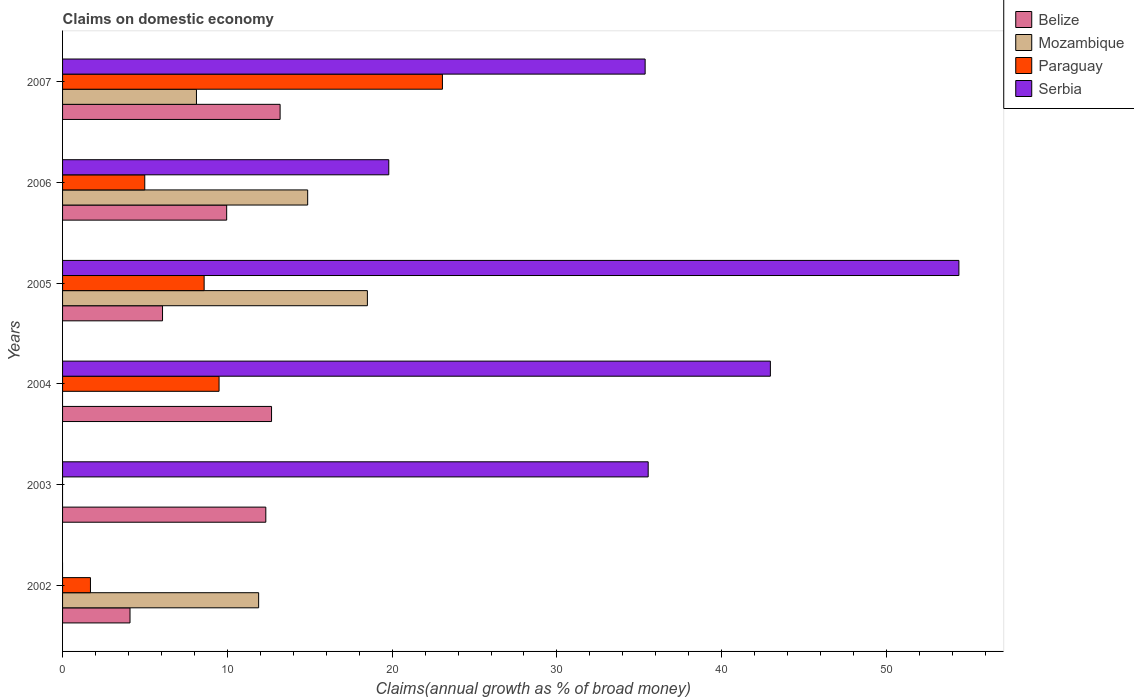How many groups of bars are there?
Your answer should be compact. 6. Are the number of bars per tick equal to the number of legend labels?
Keep it short and to the point. No. What is the percentage of broad money claimed on domestic economy in Mozambique in 2002?
Make the answer very short. 11.9. Across all years, what is the maximum percentage of broad money claimed on domestic economy in Belize?
Provide a succinct answer. 13.2. Across all years, what is the minimum percentage of broad money claimed on domestic economy in Belize?
Your answer should be compact. 4.09. In which year was the percentage of broad money claimed on domestic economy in Belize maximum?
Provide a succinct answer. 2007. What is the total percentage of broad money claimed on domestic economy in Belize in the graph?
Ensure brevity in your answer.  58.34. What is the difference between the percentage of broad money claimed on domestic economy in Paraguay in 2004 and that in 2006?
Offer a terse response. 4.51. What is the difference between the percentage of broad money claimed on domestic economy in Serbia in 2005 and the percentage of broad money claimed on domestic economy in Paraguay in 2002?
Make the answer very short. 52.7. What is the average percentage of broad money claimed on domestic economy in Paraguay per year?
Keep it short and to the point. 7.97. In the year 2002, what is the difference between the percentage of broad money claimed on domestic economy in Paraguay and percentage of broad money claimed on domestic economy in Belize?
Your response must be concise. -2.4. What is the ratio of the percentage of broad money claimed on domestic economy in Paraguay in 2002 to that in 2005?
Your answer should be very brief. 0.2. What is the difference between the highest and the second highest percentage of broad money claimed on domestic economy in Serbia?
Provide a short and direct response. 11.44. What is the difference between the highest and the lowest percentage of broad money claimed on domestic economy in Mozambique?
Provide a succinct answer. 18.5. Is it the case that in every year, the sum of the percentage of broad money claimed on domestic economy in Belize and percentage of broad money claimed on domestic economy in Mozambique is greater than the sum of percentage of broad money claimed on domestic economy in Paraguay and percentage of broad money claimed on domestic economy in Serbia?
Your answer should be compact. No. How many bars are there?
Ensure brevity in your answer.  20. Are all the bars in the graph horizontal?
Offer a terse response. Yes. How many years are there in the graph?
Provide a succinct answer. 6. Are the values on the major ticks of X-axis written in scientific E-notation?
Ensure brevity in your answer.  No. Does the graph contain any zero values?
Offer a very short reply. Yes. How many legend labels are there?
Your response must be concise. 4. What is the title of the graph?
Offer a very short reply. Claims on domestic economy. Does "Oman" appear as one of the legend labels in the graph?
Give a very brief answer. No. What is the label or title of the X-axis?
Your response must be concise. Claims(annual growth as % of broad money). What is the label or title of the Y-axis?
Keep it short and to the point. Years. What is the Claims(annual growth as % of broad money) in Belize in 2002?
Give a very brief answer. 4.09. What is the Claims(annual growth as % of broad money) of Mozambique in 2002?
Keep it short and to the point. 11.9. What is the Claims(annual growth as % of broad money) of Paraguay in 2002?
Your answer should be very brief. 1.69. What is the Claims(annual growth as % of broad money) in Serbia in 2002?
Your answer should be very brief. 0. What is the Claims(annual growth as % of broad money) in Belize in 2003?
Keep it short and to the point. 12.33. What is the Claims(annual growth as % of broad money) of Paraguay in 2003?
Your answer should be compact. 0. What is the Claims(annual growth as % of broad money) of Serbia in 2003?
Give a very brief answer. 35.54. What is the Claims(annual growth as % of broad money) in Belize in 2004?
Ensure brevity in your answer.  12.68. What is the Claims(annual growth as % of broad money) of Mozambique in 2004?
Your response must be concise. 0. What is the Claims(annual growth as % of broad money) of Paraguay in 2004?
Ensure brevity in your answer.  9.5. What is the Claims(annual growth as % of broad money) in Serbia in 2004?
Ensure brevity in your answer.  42.96. What is the Claims(annual growth as % of broad money) in Belize in 2005?
Keep it short and to the point. 6.07. What is the Claims(annual growth as % of broad money) in Mozambique in 2005?
Offer a terse response. 18.5. What is the Claims(annual growth as % of broad money) in Paraguay in 2005?
Provide a short and direct response. 8.59. What is the Claims(annual growth as % of broad money) in Serbia in 2005?
Make the answer very short. 54.4. What is the Claims(annual growth as % of broad money) of Belize in 2006?
Keep it short and to the point. 9.96. What is the Claims(annual growth as % of broad money) in Mozambique in 2006?
Provide a short and direct response. 14.87. What is the Claims(annual growth as % of broad money) of Paraguay in 2006?
Your answer should be compact. 4.99. What is the Claims(annual growth as % of broad money) of Serbia in 2006?
Make the answer very short. 19.8. What is the Claims(annual growth as % of broad money) in Belize in 2007?
Make the answer very short. 13.2. What is the Claims(annual growth as % of broad money) of Mozambique in 2007?
Give a very brief answer. 8.13. What is the Claims(annual growth as % of broad money) of Paraguay in 2007?
Offer a terse response. 23.05. What is the Claims(annual growth as % of broad money) of Serbia in 2007?
Ensure brevity in your answer.  35.36. Across all years, what is the maximum Claims(annual growth as % of broad money) of Belize?
Keep it short and to the point. 13.2. Across all years, what is the maximum Claims(annual growth as % of broad money) in Mozambique?
Give a very brief answer. 18.5. Across all years, what is the maximum Claims(annual growth as % of broad money) in Paraguay?
Ensure brevity in your answer.  23.05. Across all years, what is the maximum Claims(annual growth as % of broad money) in Serbia?
Provide a succinct answer. 54.4. Across all years, what is the minimum Claims(annual growth as % of broad money) in Belize?
Provide a short and direct response. 4.09. What is the total Claims(annual growth as % of broad money) in Belize in the graph?
Your answer should be compact. 58.34. What is the total Claims(annual growth as % of broad money) of Mozambique in the graph?
Keep it short and to the point. 53.4. What is the total Claims(annual growth as % of broad money) of Paraguay in the graph?
Make the answer very short. 47.82. What is the total Claims(annual growth as % of broad money) in Serbia in the graph?
Offer a very short reply. 188.04. What is the difference between the Claims(annual growth as % of broad money) of Belize in 2002 and that in 2003?
Offer a very short reply. -8.24. What is the difference between the Claims(annual growth as % of broad money) in Belize in 2002 and that in 2004?
Make the answer very short. -8.59. What is the difference between the Claims(annual growth as % of broad money) in Paraguay in 2002 and that in 2004?
Your answer should be compact. -7.81. What is the difference between the Claims(annual growth as % of broad money) in Belize in 2002 and that in 2005?
Make the answer very short. -1.97. What is the difference between the Claims(annual growth as % of broad money) of Mozambique in 2002 and that in 2005?
Keep it short and to the point. -6.6. What is the difference between the Claims(annual growth as % of broad money) in Paraguay in 2002 and that in 2005?
Make the answer very short. -6.9. What is the difference between the Claims(annual growth as % of broad money) of Belize in 2002 and that in 2006?
Provide a succinct answer. -5.87. What is the difference between the Claims(annual growth as % of broad money) in Mozambique in 2002 and that in 2006?
Your answer should be very brief. -2.98. What is the difference between the Claims(annual growth as % of broad money) in Paraguay in 2002 and that in 2006?
Make the answer very short. -3.3. What is the difference between the Claims(annual growth as % of broad money) in Belize in 2002 and that in 2007?
Give a very brief answer. -9.11. What is the difference between the Claims(annual growth as % of broad money) of Mozambique in 2002 and that in 2007?
Provide a succinct answer. 3.77. What is the difference between the Claims(annual growth as % of broad money) of Paraguay in 2002 and that in 2007?
Provide a succinct answer. -21.36. What is the difference between the Claims(annual growth as % of broad money) of Belize in 2003 and that in 2004?
Keep it short and to the point. -0.35. What is the difference between the Claims(annual growth as % of broad money) of Serbia in 2003 and that in 2004?
Your answer should be very brief. -7.42. What is the difference between the Claims(annual growth as % of broad money) in Belize in 2003 and that in 2005?
Offer a very short reply. 6.27. What is the difference between the Claims(annual growth as % of broad money) in Serbia in 2003 and that in 2005?
Offer a very short reply. -18.86. What is the difference between the Claims(annual growth as % of broad money) of Belize in 2003 and that in 2006?
Your answer should be compact. 2.38. What is the difference between the Claims(annual growth as % of broad money) in Serbia in 2003 and that in 2006?
Provide a short and direct response. 15.74. What is the difference between the Claims(annual growth as % of broad money) in Belize in 2003 and that in 2007?
Provide a short and direct response. -0.87. What is the difference between the Claims(annual growth as % of broad money) of Serbia in 2003 and that in 2007?
Offer a very short reply. 0.18. What is the difference between the Claims(annual growth as % of broad money) of Belize in 2004 and that in 2005?
Provide a short and direct response. 6.62. What is the difference between the Claims(annual growth as % of broad money) in Paraguay in 2004 and that in 2005?
Your answer should be very brief. 0.91. What is the difference between the Claims(annual growth as % of broad money) of Serbia in 2004 and that in 2005?
Your answer should be compact. -11.44. What is the difference between the Claims(annual growth as % of broad money) in Belize in 2004 and that in 2006?
Ensure brevity in your answer.  2.72. What is the difference between the Claims(annual growth as % of broad money) of Paraguay in 2004 and that in 2006?
Offer a very short reply. 4.51. What is the difference between the Claims(annual growth as % of broad money) in Serbia in 2004 and that in 2006?
Your answer should be very brief. 23.16. What is the difference between the Claims(annual growth as % of broad money) of Belize in 2004 and that in 2007?
Give a very brief answer. -0.52. What is the difference between the Claims(annual growth as % of broad money) in Paraguay in 2004 and that in 2007?
Give a very brief answer. -13.56. What is the difference between the Claims(annual growth as % of broad money) in Serbia in 2004 and that in 2007?
Your answer should be very brief. 7.6. What is the difference between the Claims(annual growth as % of broad money) in Belize in 2005 and that in 2006?
Keep it short and to the point. -3.89. What is the difference between the Claims(annual growth as % of broad money) in Mozambique in 2005 and that in 2006?
Ensure brevity in your answer.  3.62. What is the difference between the Claims(annual growth as % of broad money) of Paraguay in 2005 and that in 2006?
Offer a very short reply. 3.6. What is the difference between the Claims(annual growth as % of broad money) of Serbia in 2005 and that in 2006?
Offer a very short reply. 34.6. What is the difference between the Claims(annual growth as % of broad money) of Belize in 2005 and that in 2007?
Keep it short and to the point. -7.14. What is the difference between the Claims(annual growth as % of broad money) of Mozambique in 2005 and that in 2007?
Provide a succinct answer. 10.37. What is the difference between the Claims(annual growth as % of broad money) of Paraguay in 2005 and that in 2007?
Your answer should be very brief. -14.46. What is the difference between the Claims(annual growth as % of broad money) in Serbia in 2005 and that in 2007?
Give a very brief answer. 19.04. What is the difference between the Claims(annual growth as % of broad money) in Belize in 2006 and that in 2007?
Your response must be concise. -3.24. What is the difference between the Claims(annual growth as % of broad money) in Mozambique in 2006 and that in 2007?
Ensure brevity in your answer.  6.75. What is the difference between the Claims(annual growth as % of broad money) of Paraguay in 2006 and that in 2007?
Ensure brevity in your answer.  -18.06. What is the difference between the Claims(annual growth as % of broad money) of Serbia in 2006 and that in 2007?
Your answer should be very brief. -15.56. What is the difference between the Claims(annual growth as % of broad money) of Belize in 2002 and the Claims(annual growth as % of broad money) of Serbia in 2003?
Offer a terse response. -31.45. What is the difference between the Claims(annual growth as % of broad money) of Mozambique in 2002 and the Claims(annual growth as % of broad money) of Serbia in 2003?
Give a very brief answer. -23.64. What is the difference between the Claims(annual growth as % of broad money) of Paraguay in 2002 and the Claims(annual growth as % of broad money) of Serbia in 2003?
Ensure brevity in your answer.  -33.85. What is the difference between the Claims(annual growth as % of broad money) in Belize in 2002 and the Claims(annual growth as % of broad money) in Paraguay in 2004?
Keep it short and to the point. -5.4. What is the difference between the Claims(annual growth as % of broad money) in Belize in 2002 and the Claims(annual growth as % of broad money) in Serbia in 2004?
Your answer should be very brief. -38.86. What is the difference between the Claims(annual growth as % of broad money) of Mozambique in 2002 and the Claims(annual growth as % of broad money) of Paraguay in 2004?
Keep it short and to the point. 2.4. What is the difference between the Claims(annual growth as % of broad money) in Mozambique in 2002 and the Claims(annual growth as % of broad money) in Serbia in 2004?
Ensure brevity in your answer.  -31.06. What is the difference between the Claims(annual growth as % of broad money) in Paraguay in 2002 and the Claims(annual growth as % of broad money) in Serbia in 2004?
Provide a succinct answer. -41.26. What is the difference between the Claims(annual growth as % of broad money) in Belize in 2002 and the Claims(annual growth as % of broad money) in Mozambique in 2005?
Provide a succinct answer. -14.41. What is the difference between the Claims(annual growth as % of broad money) of Belize in 2002 and the Claims(annual growth as % of broad money) of Paraguay in 2005?
Keep it short and to the point. -4.5. What is the difference between the Claims(annual growth as % of broad money) in Belize in 2002 and the Claims(annual growth as % of broad money) in Serbia in 2005?
Your response must be concise. -50.3. What is the difference between the Claims(annual growth as % of broad money) in Mozambique in 2002 and the Claims(annual growth as % of broad money) in Paraguay in 2005?
Keep it short and to the point. 3.31. What is the difference between the Claims(annual growth as % of broad money) of Mozambique in 2002 and the Claims(annual growth as % of broad money) of Serbia in 2005?
Ensure brevity in your answer.  -42.5. What is the difference between the Claims(annual growth as % of broad money) in Paraguay in 2002 and the Claims(annual growth as % of broad money) in Serbia in 2005?
Offer a terse response. -52.7. What is the difference between the Claims(annual growth as % of broad money) in Belize in 2002 and the Claims(annual growth as % of broad money) in Mozambique in 2006?
Ensure brevity in your answer.  -10.78. What is the difference between the Claims(annual growth as % of broad money) of Belize in 2002 and the Claims(annual growth as % of broad money) of Paraguay in 2006?
Offer a very short reply. -0.9. What is the difference between the Claims(annual growth as % of broad money) in Belize in 2002 and the Claims(annual growth as % of broad money) in Serbia in 2006?
Keep it short and to the point. -15.7. What is the difference between the Claims(annual growth as % of broad money) in Mozambique in 2002 and the Claims(annual growth as % of broad money) in Paraguay in 2006?
Provide a succinct answer. 6.91. What is the difference between the Claims(annual growth as % of broad money) in Mozambique in 2002 and the Claims(annual growth as % of broad money) in Serbia in 2006?
Provide a succinct answer. -7.9. What is the difference between the Claims(annual growth as % of broad money) in Paraguay in 2002 and the Claims(annual growth as % of broad money) in Serbia in 2006?
Ensure brevity in your answer.  -18.1. What is the difference between the Claims(annual growth as % of broad money) of Belize in 2002 and the Claims(annual growth as % of broad money) of Mozambique in 2007?
Offer a terse response. -4.03. What is the difference between the Claims(annual growth as % of broad money) of Belize in 2002 and the Claims(annual growth as % of broad money) of Paraguay in 2007?
Provide a short and direct response. -18.96. What is the difference between the Claims(annual growth as % of broad money) in Belize in 2002 and the Claims(annual growth as % of broad money) in Serbia in 2007?
Keep it short and to the point. -31.26. What is the difference between the Claims(annual growth as % of broad money) in Mozambique in 2002 and the Claims(annual growth as % of broad money) in Paraguay in 2007?
Your answer should be compact. -11.15. What is the difference between the Claims(annual growth as % of broad money) in Mozambique in 2002 and the Claims(annual growth as % of broad money) in Serbia in 2007?
Make the answer very short. -23.46. What is the difference between the Claims(annual growth as % of broad money) of Paraguay in 2002 and the Claims(annual growth as % of broad money) of Serbia in 2007?
Offer a terse response. -33.66. What is the difference between the Claims(annual growth as % of broad money) of Belize in 2003 and the Claims(annual growth as % of broad money) of Paraguay in 2004?
Provide a succinct answer. 2.84. What is the difference between the Claims(annual growth as % of broad money) of Belize in 2003 and the Claims(annual growth as % of broad money) of Serbia in 2004?
Provide a short and direct response. -30.62. What is the difference between the Claims(annual growth as % of broad money) of Belize in 2003 and the Claims(annual growth as % of broad money) of Mozambique in 2005?
Provide a succinct answer. -6.16. What is the difference between the Claims(annual growth as % of broad money) in Belize in 2003 and the Claims(annual growth as % of broad money) in Paraguay in 2005?
Ensure brevity in your answer.  3.74. What is the difference between the Claims(annual growth as % of broad money) in Belize in 2003 and the Claims(annual growth as % of broad money) in Serbia in 2005?
Make the answer very short. -42.06. What is the difference between the Claims(annual growth as % of broad money) of Belize in 2003 and the Claims(annual growth as % of broad money) of Mozambique in 2006?
Provide a short and direct response. -2.54. What is the difference between the Claims(annual growth as % of broad money) of Belize in 2003 and the Claims(annual growth as % of broad money) of Paraguay in 2006?
Provide a succinct answer. 7.35. What is the difference between the Claims(annual growth as % of broad money) of Belize in 2003 and the Claims(annual growth as % of broad money) of Serbia in 2006?
Offer a terse response. -7.46. What is the difference between the Claims(annual growth as % of broad money) of Belize in 2003 and the Claims(annual growth as % of broad money) of Mozambique in 2007?
Your answer should be compact. 4.21. What is the difference between the Claims(annual growth as % of broad money) of Belize in 2003 and the Claims(annual growth as % of broad money) of Paraguay in 2007?
Give a very brief answer. -10.72. What is the difference between the Claims(annual growth as % of broad money) of Belize in 2003 and the Claims(annual growth as % of broad money) of Serbia in 2007?
Make the answer very short. -23.02. What is the difference between the Claims(annual growth as % of broad money) of Belize in 2004 and the Claims(annual growth as % of broad money) of Mozambique in 2005?
Make the answer very short. -5.82. What is the difference between the Claims(annual growth as % of broad money) in Belize in 2004 and the Claims(annual growth as % of broad money) in Paraguay in 2005?
Your answer should be compact. 4.09. What is the difference between the Claims(annual growth as % of broad money) in Belize in 2004 and the Claims(annual growth as % of broad money) in Serbia in 2005?
Offer a very short reply. -41.71. What is the difference between the Claims(annual growth as % of broad money) in Paraguay in 2004 and the Claims(annual growth as % of broad money) in Serbia in 2005?
Give a very brief answer. -44.9. What is the difference between the Claims(annual growth as % of broad money) of Belize in 2004 and the Claims(annual growth as % of broad money) of Mozambique in 2006?
Keep it short and to the point. -2.19. What is the difference between the Claims(annual growth as % of broad money) in Belize in 2004 and the Claims(annual growth as % of broad money) in Paraguay in 2006?
Keep it short and to the point. 7.69. What is the difference between the Claims(annual growth as % of broad money) in Belize in 2004 and the Claims(annual growth as % of broad money) in Serbia in 2006?
Make the answer very short. -7.11. What is the difference between the Claims(annual growth as % of broad money) of Paraguay in 2004 and the Claims(annual growth as % of broad money) of Serbia in 2006?
Your answer should be compact. -10.3. What is the difference between the Claims(annual growth as % of broad money) in Belize in 2004 and the Claims(annual growth as % of broad money) in Mozambique in 2007?
Keep it short and to the point. 4.56. What is the difference between the Claims(annual growth as % of broad money) in Belize in 2004 and the Claims(annual growth as % of broad money) in Paraguay in 2007?
Provide a succinct answer. -10.37. What is the difference between the Claims(annual growth as % of broad money) of Belize in 2004 and the Claims(annual growth as % of broad money) of Serbia in 2007?
Your response must be concise. -22.67. What is the difference between the Claims(annual growth as % of broad money) in Paraguay in 2004 and the Claims(annual growth as % of broad money) in Serbia in 2007?
Provide a short and direct response. -25.86. What is the difference between the Claims(annual growth as % of broad money) of Belize in 2005 and the Claims(annual growth as % of broad money) of Mozambique in 2006?
Give a very brief answer. -8.81. What is the difference between the Claims(annual growth as % of broad money) of Belize in 2005 and the Claims(annual growth as % of broad money) of Paraguay in 2006?
Your response must be concise. 1.08. What is the difference between the Claims(annual growth as % of broad money) in Belize in 2005 and the Claims(annual growth as % of broad money) in Serbia in 2006?
Give a very brief answer. -13.73. What is the difference between the Claims(annual growth as % of broad money) in Mozambique in 2005 and the Claims(annual growth as % of broad money) in Paraguay in 2006?
Offer a terse response. 13.51. What is the difference between the Claims(annual growth as % of broad money) of Mozambique in 2005 and the Claims(annual growth as % of broad money) of Serbia in 2006?
Provide a succinct answer. -1.3. What is the difference between the Claims(annual growth as % of broad money) of Paraguay in 2005 and the Claims(annual growth as % of broad money) of Serbia in 2006?
Make the answer very short. -11.21. What is the difference between the Claims(annual growth as % of broad money) in Belize in 2005 and the Claims(annual growth as % of broad money) in Mozambique in 2007?
Ensure brevity in your answer.  -2.06. What is the difference between the Claims(annual growth as % of broad money) in Belize in 2005 and the Claims(annual growth as % of broad money) in Paraguay in 2007?
Give a very brief answer. -16.99. What is the difference between the Claims(annual growth as % of broad money) of Belize in 2005 and the Claims(annual growth as % of broad money) of Serbia in 2007?
Your response must be concise. -29.29. What is the difference between the Claims(annual growth as % of broad money) of Mozambique in 2005 and the Claims(annual growth as % of broad money) of Paraguay in 2007?
Your answer should be very brief. -4.55. What is the difference between the Claims(annual growth as % of broad money) of Mozambique in 2005 and the Claims(annual growth as % of broad money) of Serbia in 2007?
Provide a short and direct response. -16.86. What is the difference between the Claims(annual growth as % of broad money) in Paraguay in 2005 and the Claims(annual growth as % of broad money) in Serbia in 2007?
Give a very brief answer. -26.76. What is the difference between the Claims(annual growth as % of broad money) in Belize in 2006 and the Claims(annual growth as % of broad money) in Mozambique in 2007?
Provide a succinct answer. 1.83. What is the difference between the Claims(annual growth as % of broad money) of Belize in 2006 and the Claims(annual growth as % of broad money) of Paraguay in 2007?
Ensure brevity in your answer.  -13.09. What is the difference between the Claims(annual growth as % of broad money) in Belize in 2006 and the Claims(annual growth as % of broad money) in Serbia in 2007?
Give a very brief answer. -25.4. What is the difference between the Claims(annual growth as % of broad money) of Mozambique in 2006 and the Claims(annual growth as % of broad money) of Paraguay in 2007?
Keep it short and to the point. -8.18. What is the difference between the Claims(annual growth as % of broad money) of Mozambique in 2006 and the Claims(annual growth as % of broad money) of Serbia in 2007?
Your response must be concise. -20.48. What is the difference between the Claims(annual growth as % of broad money) in Paraguay in 2006 and the Claims(annual growth as % of broad money) in Serbia in 2007?
Provide a succinct answer. -30.37. What is the average Claims(annual growth as % of broad money) in Belize per year?
Provide a short and direct response. 9.72. What is the average Claims(annual growth as % of broad money) in Mozambique per year?
Your response must be concise. 8.9. What is the average Claims(annual growth as % of broad money) in Paraguay per year?
Your answer should be very brief. 7.97. What is the average Claims(annual growth as % of broad money) in Serbia per year?
Your answer should be very brief. 31.34. In the year 2002, what is the difference between the Claims(annual growth as % of broad money) in Belize and Claims(annual growth as % of broad money) in Mozambique?
Your response must be concise. -7.81. In the year 2002, what is the difference between the Claims(annual growth as % of broad money) in Belize and Claims(annual growth as % of broad money) in Paraguay?
Provide a short and direct response. 2.4. In the year 2002, what is the difference between the Claims(annual growth as % of broad money) in Mozambique and Claims(annual growth as % of broad money) in Paraguay?
Provide a short and direct response. 10.21. In the year 2003, what is the difference between the Claims(annual growth as % of broad money) of Belize and Claims(annual growth as % of broad money) of Serbia?
Ensure brevity in your answer.  -23.2. In the year 2004, what is the difference between the Claims(annual growth as % of broad money) of Belize and Claims(annual growth as % of broad money) of Paraguay?
Offer a very short reply. 3.19. In the year 2004, what is the difference between the Claims(annual growth as % of broad money) of Belize and Claims(annual growth as % of broad money) of Serbia?
Ensure brevity in your answer.  -30.27. In the year 2004, what is the difference between the Claims(annual growth as % of broad money) of Paraguay and Claims(annual growth as % of broad money) of Serbia?
Keep it short and to the point. -33.46. In the year 2005, what is the difference between the Claims(annual growth as % of broad money) of Belize and Claims(annual growth as % of broad money) of Mozambique?
Offer a terse response. -12.43. In the year 2005, what is the difference between the Claims(annual growth as % of broad money) of Belize and Claims(annual growth as % of broad money) of Paraguay?
Provide a short and direct response. -2.53. In the year 2005, what is the difference between the Claims(annual growth as % of broad money) of Belize and Claims(annual growth as % of broad money) of Serbia?
Your answer should be very brief. -48.33. In the year 2005, what is the difference between the Claims(annual growth as % of broad money) of Mozambique and Claims(annual growth as % of broad money) of Paraguay?
Offer a terse response. 9.91. In the year 2005, what is the difference between the Claims(annual growth as % of broad money) of Mozambique and Claims(annual growth as % of broad money) of Serbia?
Offer a terse response. -35.9. In the year 2005, what is the difference between the Claims(annual growth as % of broad money) of Paraguay and Claims(annual growth as % of broad money) of Serbia?
Provide a short and direct response. -45.8. In the year 2006, what is the difference between the Claims(annual growth as % of broad money) in Belize and Claims(annual growth as % of broad money) in Mozambique?
Your answer should be compact. -4.92. In the year 2006, what is the difference between the Claims(annual growth as % of broad money) of Belize and Claims(annual growth as % of broad money) of Paraguay?
Your answer should be compact. 4.97. In the year 2006, what is the difference between the Claims(annual growth as % of broad money) in Belize and Claims(annual growth as % of broad money) in Serbia?
Your response must be concise. -9.84. In the year 2006, what is the difference between the Claims(annual growth as % of broad money) of Mozambique and Claims(annual growth as % of broad money) of Paraguay?
Offer a terse response. 9.89. In the year 2006, what is the difference between the Claims(annual growth as % of broad money) of Mozambique and Claims(annual growth as % of broad money) of Serbia?
Offer a very short reply. -4.92. In the year 2006, what is the difference between the Claims(annual growth as % of broad money) of Paraguay and Claims(annual growth as % of broad money) of Serbia?
Offer a terse response. -14.81. In the year 2007, what is the difference between the Claims(annual growth as % of broad money) in Belize and Claims(annual growth as % of broad money) in Mozambique?
Provide a succinct answer. 5.08. In the year 2007, what is the difference between the Claims(annual growth as % of broad money) of Belize and Claims(annual growth as % of broad money) of Paraguay?
Offer a very short reply. -9.85. In the year 2007, what is the difference between the Claims(annual growth as % of broad money) in Belize and Claims(annual growth as % of broad money) in Serbia?
Your answer should be compact. -22.15. In the year 2007, what is the difference between the Claims(annual growth as % of broad money) in Mozambique and Claims(annual growth as % of broad money) in Paraguay?
Provide a short and direct response. -14.93. In the year 2007, what is the difference between the Claims(annual growth as % of broad money) in Mozambique and Claims(annual growth as % of broad money) in Serbia?
Your answer should be compact. -27.23. In the year 2007, what is the difference between the Claims(annual growth as % of broad money) in Paraguay and Claims(annual growth as % of broad money) in Serbia?
Your answer should be compact. -12.3. What is the ratio of the Claims(annual growth as % of broad money) of Belize in 2002 to that in 2003?
Keep it short and to the point. 0.33. What is the ratio of the Claims(annual growth as % of broad money) of Belize in 2002 to that in 2004?
Give a very brief answer. 0.32. What is the ratio of the Claims(annual growth as % of broad money) in Paraguay in 2002 to that in 2004?
Offer a terse response. 0.18. What is the ratio of the Claims(annual growth as % of broad money) of Belize in 2002 to that in 2005?
Your response must be concise. 0.67. What is the ratio of the Claims(annual growth as % of broad money) of Mozambique in 2002 to that in 2005?
Make the answer very short. 0.64. What is the ratio of the Claims(annual growth as % of broad money) of Paraguay in 2002 to that in 2005?
Ensure brevity in your answer.  0.2. What is the ratio of the Claims(annual growth as % of broad money) in Belize in 2002 to that in 2006?
Ensure brevity in your answer.  0.41. What is the ratio of the Claims(annual growth as % of broad money) of Paraguay in 2002 to that in 2006?
Offer a very short reply. 0.34. What is the ratio of the Claims(annual growth as % of broad money) in Belize in 2002 to that in 2007?
Provide a succinct answer. 0.31. What is the ratio of the Claims(annual growth as % of broad money) in Mozambique in 2002 to that in 2007?
Your answer should be very brief. 1.46. What is the ratio of the Claims(annual growth as % of broad money) in Paraguay in 2002 to that in 2007?
Ensure brevity in your answer.  0.07. What is the ratio of the Claims(annual growth as % of broad money) of Belize in 2003 to that in 2004?
Provide a succinct answer. 0.97. What is the ratio of the Claims(annual growth as % of broad money) of Serbia in 2003 to that in 2004?
Provide a short and direct response. 0.83. What is the ratio of the Claims(annual growth as % of broad money) of Belize in 2003 to that in 2005?
Your answer should be compact. 2.03. What is the ratio of the Claims(annual growth as % of broad money) in Serbia in 2003 to that in 2005?
Your answer should be compact. 0.65. What is the ratio of the Claims(annual growth as % of broad money) in Belize in 2003 to that in 2006?
Ensure brevity in your answer.  1.24. What is the ratio of the Claims(annual growth as % of broad money) of Serbia in 2003 to that in 2006?
Make the answer very short. 1.8. What is the ratio of the Claims(annual growth as % of broad money) of Belize in 2003 to that in 2007?
Make the answer very short. 0.93. What is the ratio of the Claims(annual growth as % of broad money) in Belize in 2004 to that in 2005?
Provide a succinct answer. 2.09. What is the ratio of the Claims(annual growth as % of broad money) of Paraguay in 2004 to that in 2005?
Ensure brevity in your answer.  1.11. What is the ratio of the Claims(annual growth as % of broad money) of Serbia in 2004 to that in 2005?
Provide a short and direct response. 0.79. What is the ratio of the Claims(annual growth as % of broad money) in Belize in 2004 to that in 2006?
Provide a short and direct response. 1.27. What is the ratio of the Claims(annual growth as % of broad money) in Paraguay in 2004 to that in 2006?
Offer a terse response. 1.9. What is the ratio of the Claims(annual growth as % of broad money) in Serbia in 2004 to that in 2006?
Your response must be concise. 2.17. What is the ratio of the Claims(annual growth as % of broad money) of Belize in 2004 to that in 2007?
Provide a succinct answer. 0.96. What is the ratio of the Claims(annual growth as % of broad money) in Paraguay in 2004 to that in 2007?
Provide a short and direct response. 0.41. What is the ratio of the Claims(annual growth as % of broad money) in Serbia in 2004 to that in 2007?
Your response must be concise. 1.22. What is the ratio of the Claims(annual growth as % of broad money) of Belize in 2005 to that in 2006?
Provide a succinct answer. 0.61. What is the ratio of the Claims(annual growth as % of broad money) of Mozambique in 2005 to that in 2006?
Provide a succinct answer. 1.24. What is the ratio of the Claims(annual growth as % of broad money) in Paraguay in 2005 to that in 2006?
Offer a terse response. 1.72. What is the ratio of the Claims(annual growth as % of broad money) in Serbia in 2005 to that in 2006?
Your response must be concise. 2.75. What is the ratio of the Claims(annual growth as % of broad money) of Belize in 2005 to that in 2007?
Your answer should be very brief. 0.46. What is the ratio of the Claims(annual growth as % of broad money) in Mozambique in 2005 to that in 2007?
Your answer should be very brief. 2.28. What is the ratio of the Claims(annual growth as % of broad money) of Paraguay in 2005 to that in 2007?
Ensure brevity in your answer.  0.37. What is the ratio of the Claims(annual growth as % of broad money) in Serbia in 2005 to that in 2007?
Provide a short and direct response. 1.54. What is the ratio of the Claims(annual growth as % of broad money) in Belize in 2006 to that in 2007?
Your response must be concise. 0.75. What is the ratio of the Claims(annual growth as % of broad money) of Mozambique in 2006 to that in 2007?
Your answer should be very brief. 1.83. What is the ratio of the Claims(annual growth as % of broad money) of Paraguay in 2006 to that in 2007?
Provide a short and direct response. 0.22. What is the ratio of the Claims(annual growth as % of broad money) of Serbia in 2006 to that in 2007?
Offer a very short reply. 0.56. What is the difference between the highest and the second highest Claims(annual growth as % of broad money) in Belize?
Your answer should be very brief. 0.52. What is the difference between the highest and the second highest Claims(annual growth as % of broad money) of Mozambique?
Ensure brevity in your answer.  3.62. What is the difference between the highest and the second highest Claims(annual growth as % of broad money) in Paraguay?
Offer a terse response. 13.56. What is the difference between the highest and the second highest Claims(annual growth as % of broad money) of Serbia?
Offer a very short reply. 11.44. What is the difference between the highest and the lowest Claims(annual growth as % of broad money) in Belize?
Provide a short and direct response. 9.11. What is the difference between the highest and the lowest Claims(annual growth as % of broad money) of Mozambique?
Make the answer very short. 18.5. What is the difference between the highest and the lowest Claims(annual growth as % of broad money) in Paraguay?
Your response must be concise. 23.05. What is the difference between the highest and the lowest Claims(annual growth as % of broad money) in Serbia?
Provide a short and direct response. 54.4. 